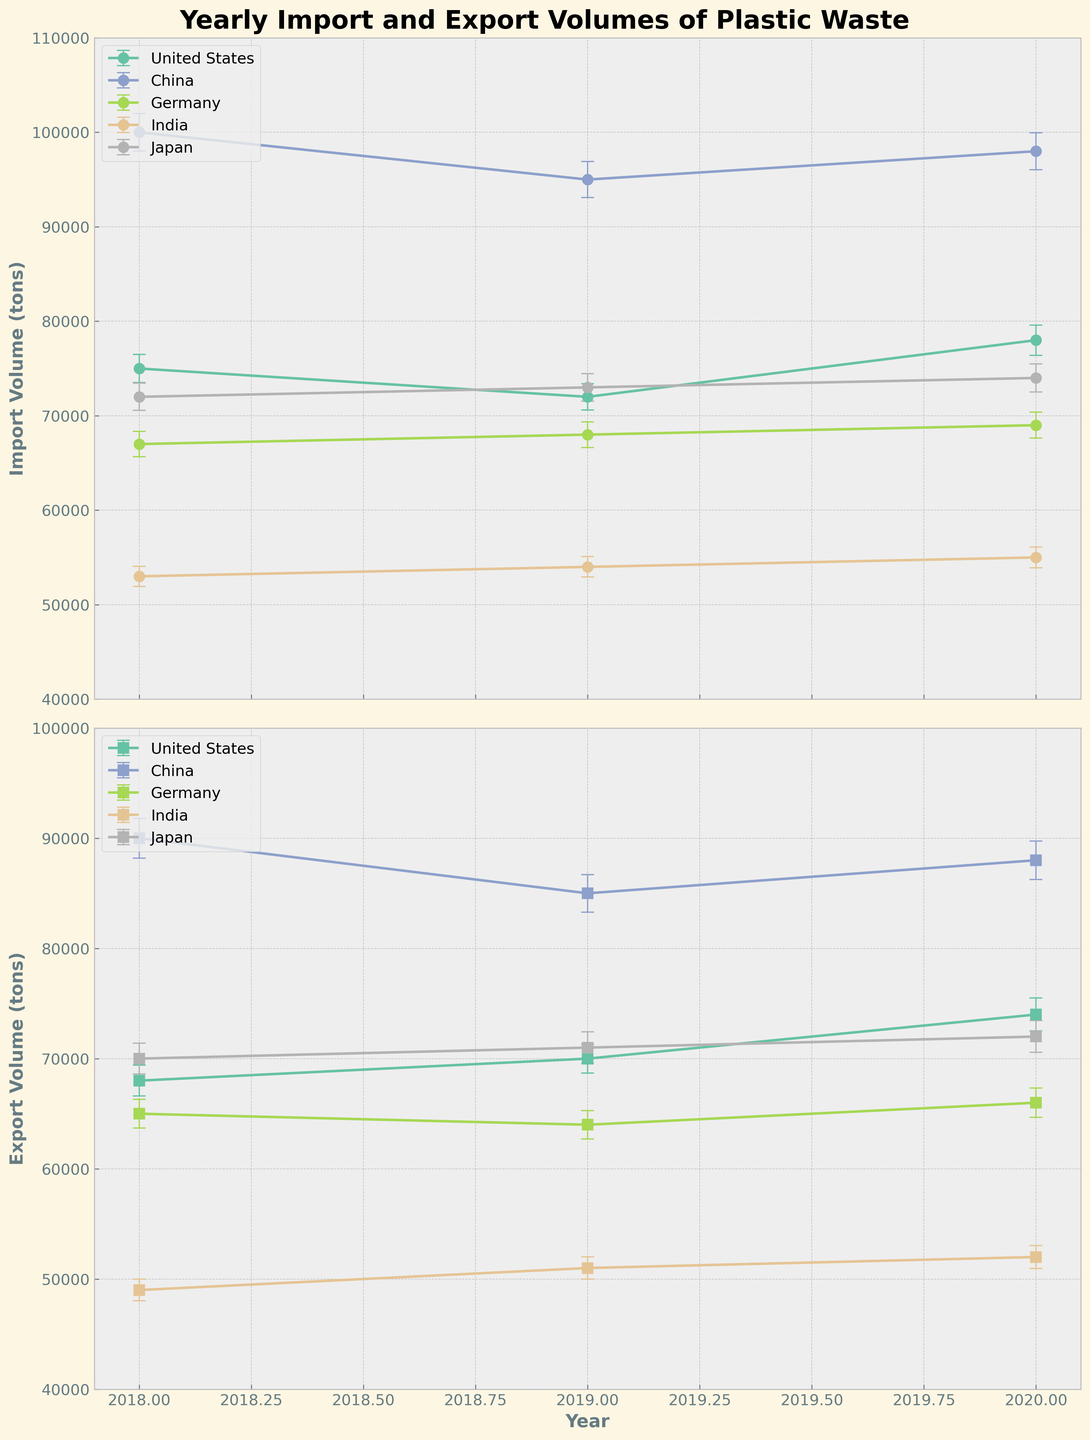What is the title of the figure? The title of the figure is displayed at the top center of the plot. It reads 'Yearly Import and Export Volumes of Plastic Waste'.
Answer: Yearly Import and Export Volumes of Plastic Waste Which country shows the highest import volume in 2020? The line for import volumes in 2020 shows that China has the highest import volume compared to other countries, which is 98,000 tons as identified by tracing the color corresponding to China.
Answer: China Which country had the lowest export volume in 2019? Observing the export volume lines in 2019, India has the lowest export volume at 51,000 tons, identifiable by tracing the color for India.
Answer: India What is the difference in export volumes for the United States between 2018 and 2020? For the United States, the export volume in 2018 is 68,000 tons and in 2020 is 74,000 tons. The difference is calculated as 74,000 - 68,000.
Answer: 6,000 tons How does the import volume trend for Germany change from 2018 to 2020? By observing Germany's import volume line, it shows a consistent upward trend. It starts from 67,000 tons in 2018, increases to 68,000 tons in 2019, and further to 69,000 tons in 2020.
Answer: Increasing trend Which country had the smallest margin of error for export volume in 2018? By looking at the error bars for export volumes in 2018, Germany has the smallest export error margin of 1,300 tons.
Answer: Germany Compare the import volumes of China and Japan in 2019. Which is greater? The import volume for China in 2019 is 95,000 tons and for Japan, it is 73,000 tons. By comparing these values, China's import volume is greater.
Answer: China For which country did the export volume increase the most from 2018 to 2019? By comparing the export volumes for each country from 2018 to 2019, the United States export volume increased from 68,000 to 70,000 tons, an increase of 2,000 tons. For other countries, increases are smaller or negative.
Answer: United States What are the import volumes for India across the years? The import volume for India is shown as 53,000 tons in 2018, 54,000 tons in 2019, and 55,000 tons in 2020. This sequence is seen by tracing India's import line.
Answer: 53,000, 54,000, 55,000 tons Identify the country with the most balanced import and export volumes in 2020. By comparing import and export volumes for 2020, Germany has the most balanced values with import at 69,000 tons and export at 66,000 tons, showing the least difference between import and export values.
Answer: Germany 